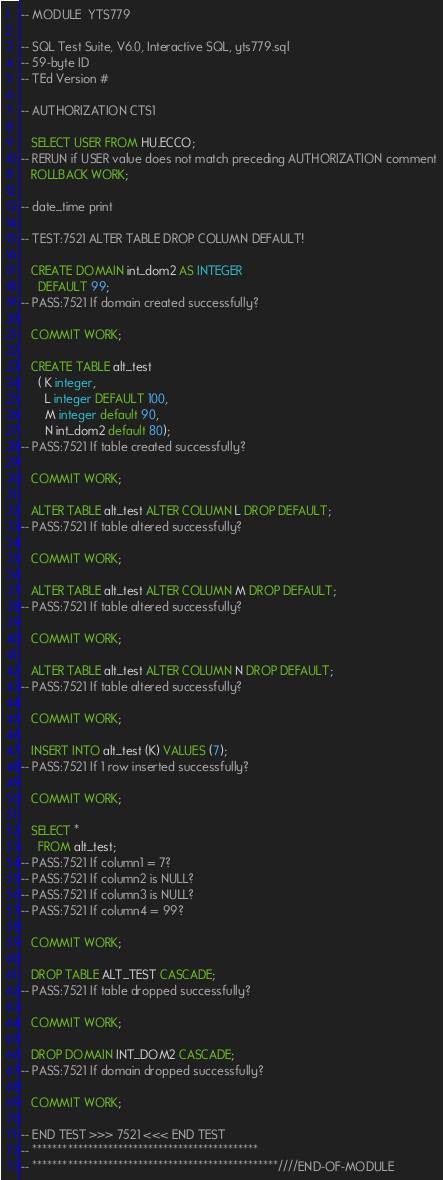<code> <loc_0><loc_0><loc_500><loc_500><_SQL_>-- MODULE  YTS779  

-- SQL Test Suite, V6.0, Interactive SQL, yts779.sql
-- 59-byte ID
-- TEd Version #

-- AUTHORIZATION CTS1              

   SELECT USER FROM HU.ECCO;
-- RERUN if USER value does not match preceding AUTHORIZATION comment
   ROLLBACK WORK;

-- date_time print

-- TEST:7521 ALTER TABLE DROP COLUMN DEFAULT!

   CREATE DOMAIN int_dom2 AS INTEGER
     DEFAULT 99;
-- PASS:7521 If domain created successfully?

   COMMIT WORK;

   CREATE TABLE alt_test
     ( K integer,
       L integer DEFAULT 100,
       M integer default 90,
       N int_dom2 default 80);
-- PASS:7521 If table created successfully?

   COMMIT WORK;

   ALTER TABLE alt_test ALTER COLUMN L DROP DEFAULT;
-- PASS:7521 If table altered successfully?

   COMMIT WORK;

   ALTER TABLE alt_test ALTER COLUMN M DROP DEFAULT;
-- PASS:7521 If table altered successfully?

   COMMIT WORK;

   ALTER TABLE alt_test ALTER COLUMN N DROP DEFAULT;
-- PASS:7521 If table altered successfully?

   COMMIT WORK;

   INSERT INTO alt_test (K) VALUES (7);
-- PASS:7521 If 1 row inserted successfully?

   COMMIT WORK;

   SELECT * 
     FROM alt_test;
-- PASS:7521 If column1 = 7?
-- PASS:7521 If column2 is NULL?
-- PASS:7521 If column3 is NULL?
-- PASS:7521 If column4 = 99?

   COMMIT WORK;

   DROP TABLE ALT_TEST CASCADE;
-- PASS:7521 If table dropped successfully?

   COMMIT WORK;

   DROP DOMAIN INT_DOM2 CASCADE;
-- PASS:7521 If domain dropped successfully?

   COMMIT WORK;

-- END TEST >>> 7521 <<< END TEST
-- *********************************************
-- *************************************************////END-OF-MODULE
</code> 